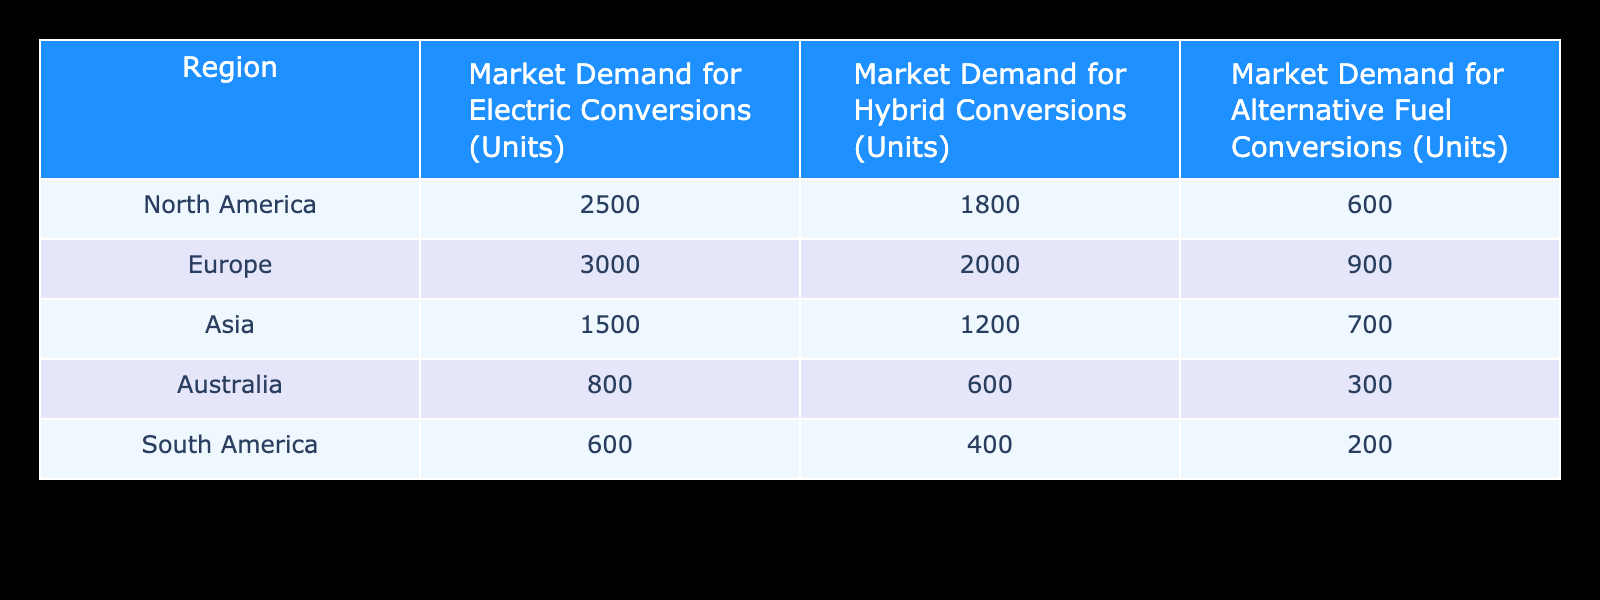What is the market demand for electric conversions in North America? The table states the market demand for electric conversions in North America is listed directly in the corresponding row under the "Market Demand for Electric Conversions (Units)" column, which shows 2500 units.
Answer: 2500 Which region has the highest demand for hybrid conversions? To find this, I look at the values listed under the "Market Demand for Hybrid Conversions (Units)" column. The values are: North America (1800), Europe (2000), Asia (1200), Australia (600), and South America (400). The highest value is 2000, which corresponds to Europe.
Answer: Europe What is the total market demand for alternative fuel conversions across all regions? I need to sum the values in the "Market Demand for Alternative Fuel Conversions (Units)" column: 600 + 900 + 700 + 300 + 200 = 2700. Thus, the total market demand is 2700 units.
Answer: 2700 Is the market demand for hybrid conversions in Asia higher than in Australia? I compare the numbers in the Asian demand (1200) with the Australian demand (600) from the "Market Demand for Hybrid Conversions (Units)" column. Since 1200 is greater than 600, the statement is true.
Answer: Yes What is the difference between the market demand for electric conversions in Europe and South America? I find the values for electric conversions: Europe (3000) and South America (600). The difference is calculated as 3000 - 600 = 2400. Therefore, the difference in demand is 2400 units.
Answer: 2400 Which region has the lowest demand for alternative fuel conversions? I will identify the lowest number in the "Market Demand for Alternative Fuel Conversions (Units)" column: North America (600), Europe (900), Asia (700), Australia (300), and South America (200). The smallest value is 200, which is for South America.
Answer: South America What is the average market demand for electric conversions across all regions? To calculate the average, I total the electric conversions: 2500 (North America) + 3000 (Europe) + 1500 (Asia) + 800 (Australia) + 600 (South America) = 10000. Then divide by the number of regions (5): 10000/5 = 2000. The average demand is 2000 units.
Answer: 2000 Do the total electric conversions in North America and Europe exceed those in Asia? First, I sum the electric conversions for North America (2500) and Europe (3000) to get 5500. Then, I compare this to Asia's electric conversions (1500). Since 5500 is greater than 1500, the statement is true.
Answer: Yes What is the total demand for electric and hybrid conversions in Australia? I will add the demand for electric conversions in Australia (800) to the demand for hybrid conversions in Australia (600). Thus, 800 + 600 = 1400. The total demand for these conversions in Australia is 1400 units.
Answer: 1400 